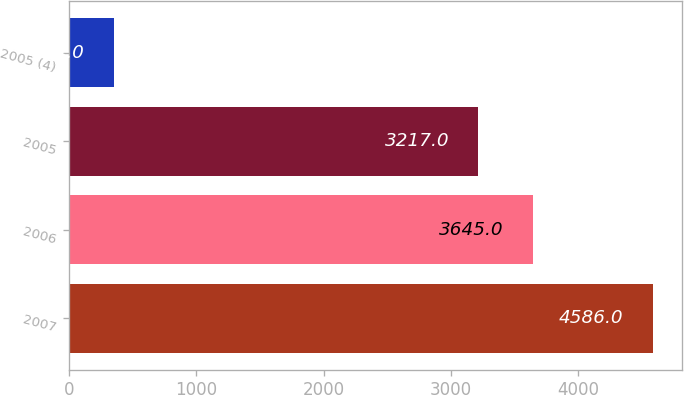Convert chart. <chart><loc_0><loc_0><loc_500><loc_500><bar_chart><fcel>2007<fcel>2006<fcel>2005<fcel>2005 (4)<nl><fcel>4586<fcel>3645<fcel>3217<fcel>354<nl></chart> 